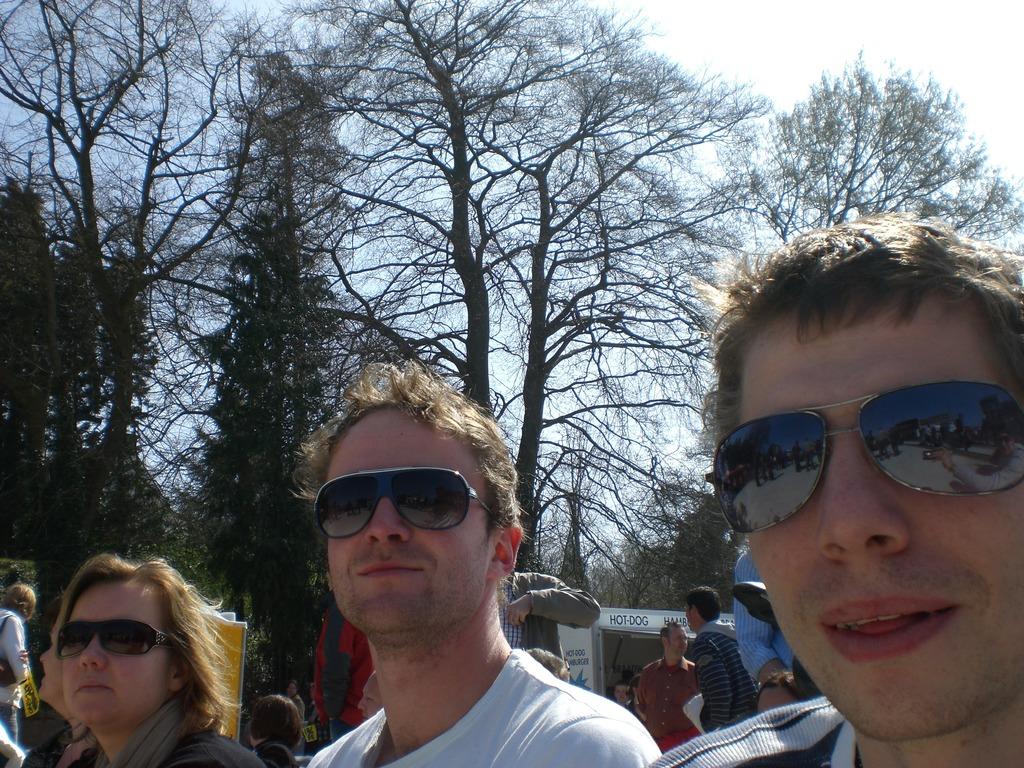How many have sun glasses?
Your answer should be very brief. 3. 